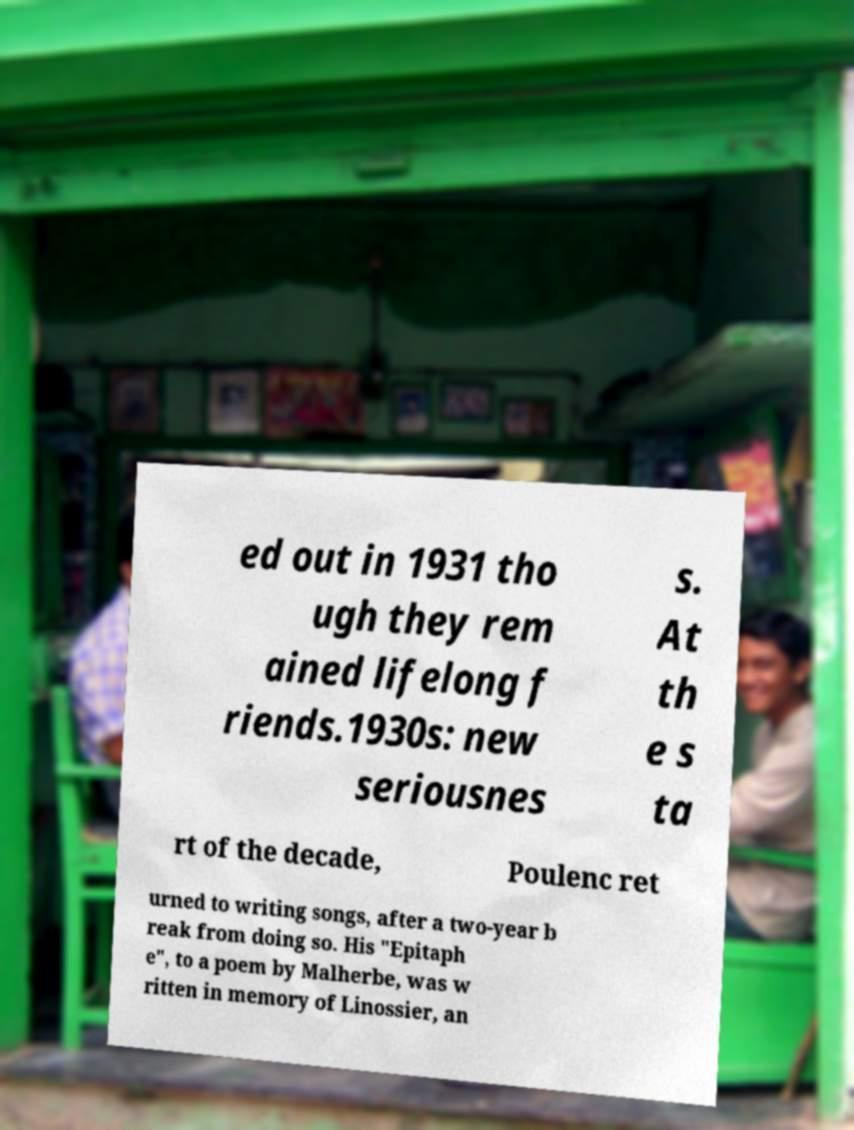For documentation purposes, I need the text within this image transcribed. Could you provide that? ed out in 1931 tho ugh they rem ained lifelong f riends.1930s: new seriousnes s. At th e s ta rt of the decade, Poulenc ret urned to writing songs, after a two-year b reak from doing so. His "Epitaph e", to a poem by Malherbe, was w ritten in memory of Linossier, an 